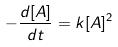Convert formula to latex. <formula><loc_0><loc_0><loc_500><loc_500>- \frac { d [ A ] } { d t } = k [ A ] ^ { 2 }</formula> 